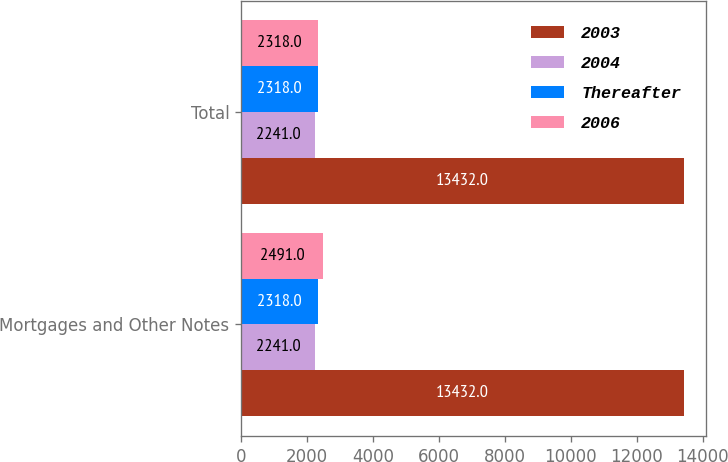Convert chart to OTSL. <chart><loc_0><loc_0><loc_500><loc_500><stacked_bar_chart><ecel><fcel>Mortgages and Other Notes<fcel>Total<nl><fcel>2003<fcel>13432<fcel>13432<nl><fcel>2004<fcel>2241<fcel>2241<nl><fcel>Thereafter<fcel>2318<fcel>2318<nl><fcel>2006<fcel>2491<fcel>2318<nl></chart> 